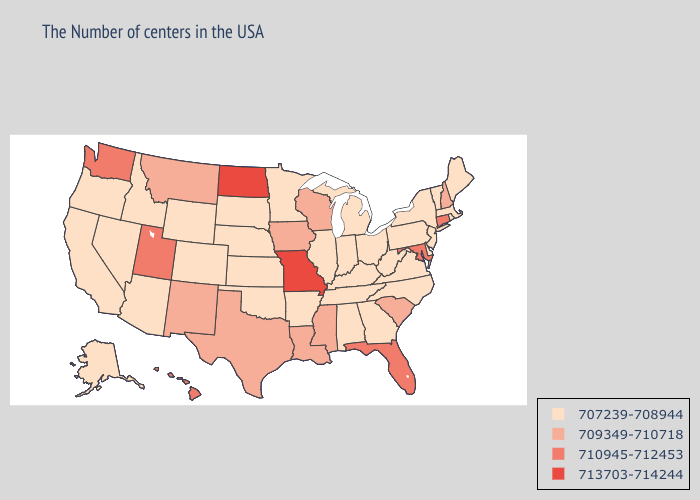What is the lowest value in states that border Oklahoma?
Concise answer only. 707239-708944. Which states have the highest value in the USA?
Short answer required. Missouri, North Dakota. What is the lowest value in the South?
Quick response, please. 707239-708944. Does Texas have the lowest value in the South?
Write a very short answer. No. What is the lowest value in states that border Montana?
Give a very brief answer. 707239-708944. Does South Dakota have the highest value in the USA?
Concise answer only. No. What is the value of Iowa?
Keep it brief. 709349-710718. Among the states that border Texas , does Arkansas have the highest value?
Quick response, please. No. What is the value of Mississippi?
Give a very brief answer. 709349-710718. Name the states that have a value in the range 710945-712453?
Be succinct. Connecticut, Maryland, Florida, Utah, Washington, Hawaii. Name the states that have a value in the range 707239-708944?
Keep it brief. Maine, Massachusetts, Rhode Island, Vermont, New York, New Jersey, Delaware, Pennsylvania, Virginia, North Carolina, West Virginia, Ohio, Georgia, Michigan, Kentucky, Indiana, Alabama, Tennessee, Illinois, Arkansas, Minnesota, Kansas, Nebraska, Oklahoma, South Dakota, Wyoming, Colorado, Arizona, Idaho, Nevada, California, Oregon, Alaska. What is the lowest value in states that border South Dakota?
Write a very short answer. 707239-708944. Which states have the lowest value in the MidWest?
Quick response, please. Ohio, Michigan, Indiana, Illinois, Minnesota, Kansas, Nebraska, South Dakota. Does Michigan have the lowest value in the USA?
Keep it brief. Yes. Does Tennessee have the same value as Missouri?
Write a very short answer. No. 